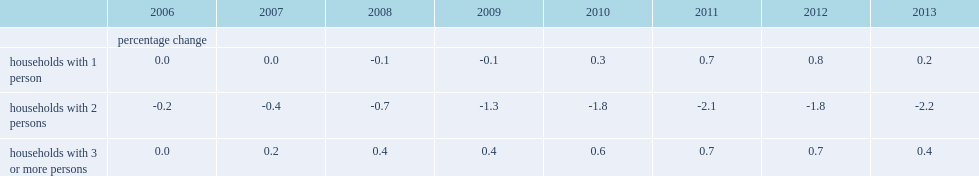Could you parse the entire table as a dict? {'header': ['', '2006', '2007', '2008', '2009', '2010', '2011', '2012', '2013'], 'rows': [['', 'percentage change', '', '', '', '', '', '', ''], ['households with 1 person', '0.0', '0.0', '-0.1', '-0.1', '0.3', '0.7', '0.8', '0.2'], ['households with 2 persons', '-0.2', '-0.4', '-0.7', '-1.3', '-1.8', '-2.1', '-1.8', '-2.2'], ['households with 3 or more persons', '0.0', '0.2', '0.4', '0.4', '0.6', '0.7', '0.7', '0.4']]} The number of which kind of households was downwardly revised for all the years? Households with 2 persons. The number of which kind of households was unchanged or upwardly revised for all the years? Households with 3 or more persons. What were the households that witnessed relatively small changes all the years? Households with 1 person households with 3 or more persons. Which kind of households experienced a relatively larger change all the years. Households with 2 persons. 